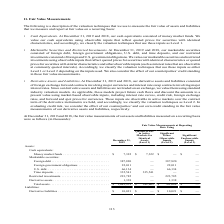According to First Solar's financial document, What is the value of money market funds as of December 31, 2019? According to the financial document, $7,322 (in thousands). The relevant text states: "Assets: Cash equivalents: Money market funds . $ 7,322 $ 7,322 $ — $ — Marketable securities: Foreign debt . 387,820 — 387,820 — Foreign government obliga..." Also, What is the value of foreign debt as of December 31, 2019? According to the financial document, 387,820 (in thousands). The relevant text states: "322 $ — $ — Marketable securities: Foreign debt . 387,820 — 387,820 — Foreign government obligations . 22,011 — 22,011 — U.S. debt. . 66,134 — 66,134 — Time..." Also, What is the value of foreign government obligations as of December 31, 2019? According to the financial document, 22,011 (in thousands). The relevant text states: ",820 — 387,820 — Foreign government obligations . 22,011 — 22,011 — U.S. debt. . 66,134 — 66,134 — Time deposits. . 335,541 335,541 — — Restricted investmen..." Also, can you calculate: What is the difference in the value of money market funds and foreign debt as of December 31, 2019? Based on the calculation: 387,820-7,322, the result is 380498 (in thousands). This is based on the information: "322 $ — $ — Marketable securities: Foreign debt . 387,820 — 387,820 — Foreign government obligations . 22,011 — 22,011 — U.S. debt. . 66,134 — 66,134 — Time Assets: Cash equivalents: Money market fund..." The key data points involved are: 387,820, 7,322. Also, can you calculate: What is the percentage constitution of money market funds among the total assets as of December 31, 2019? Based on the calculation: 7,322/1,043,951, the result is 0.7 (percentage). This is based on the information: "vative assets . 1,338 — 1,338 — Total assets. . $ 1,043,951 $ 342,863 $ 701,088 $ — Liabilities: Derivative liabilities . $ 10,021 $ — $ 10,021 $ — Assets: Cash equivalents: Money market funds . $ 7,3..." The key data points involved are: 1,043,951, 7,322. Also, can you calculate: What is the difference in the value of time deposits and restricted investments as of December 31, 2019? Based on the calculation: 335,541-223,785, the result is 111756 (in thousands). This is based on the information: "— U.S. debt. . 66,134 — 66,134 — Time deposits. . 335,541 335,541 — — Restricted investments. . 223,785 — 223,785 — Derivative assets . 1,338 — 1,338 — Total . . 335,541 335,541 — — Restricted investm..." The key data points involved are: 223,785, 335,541. 